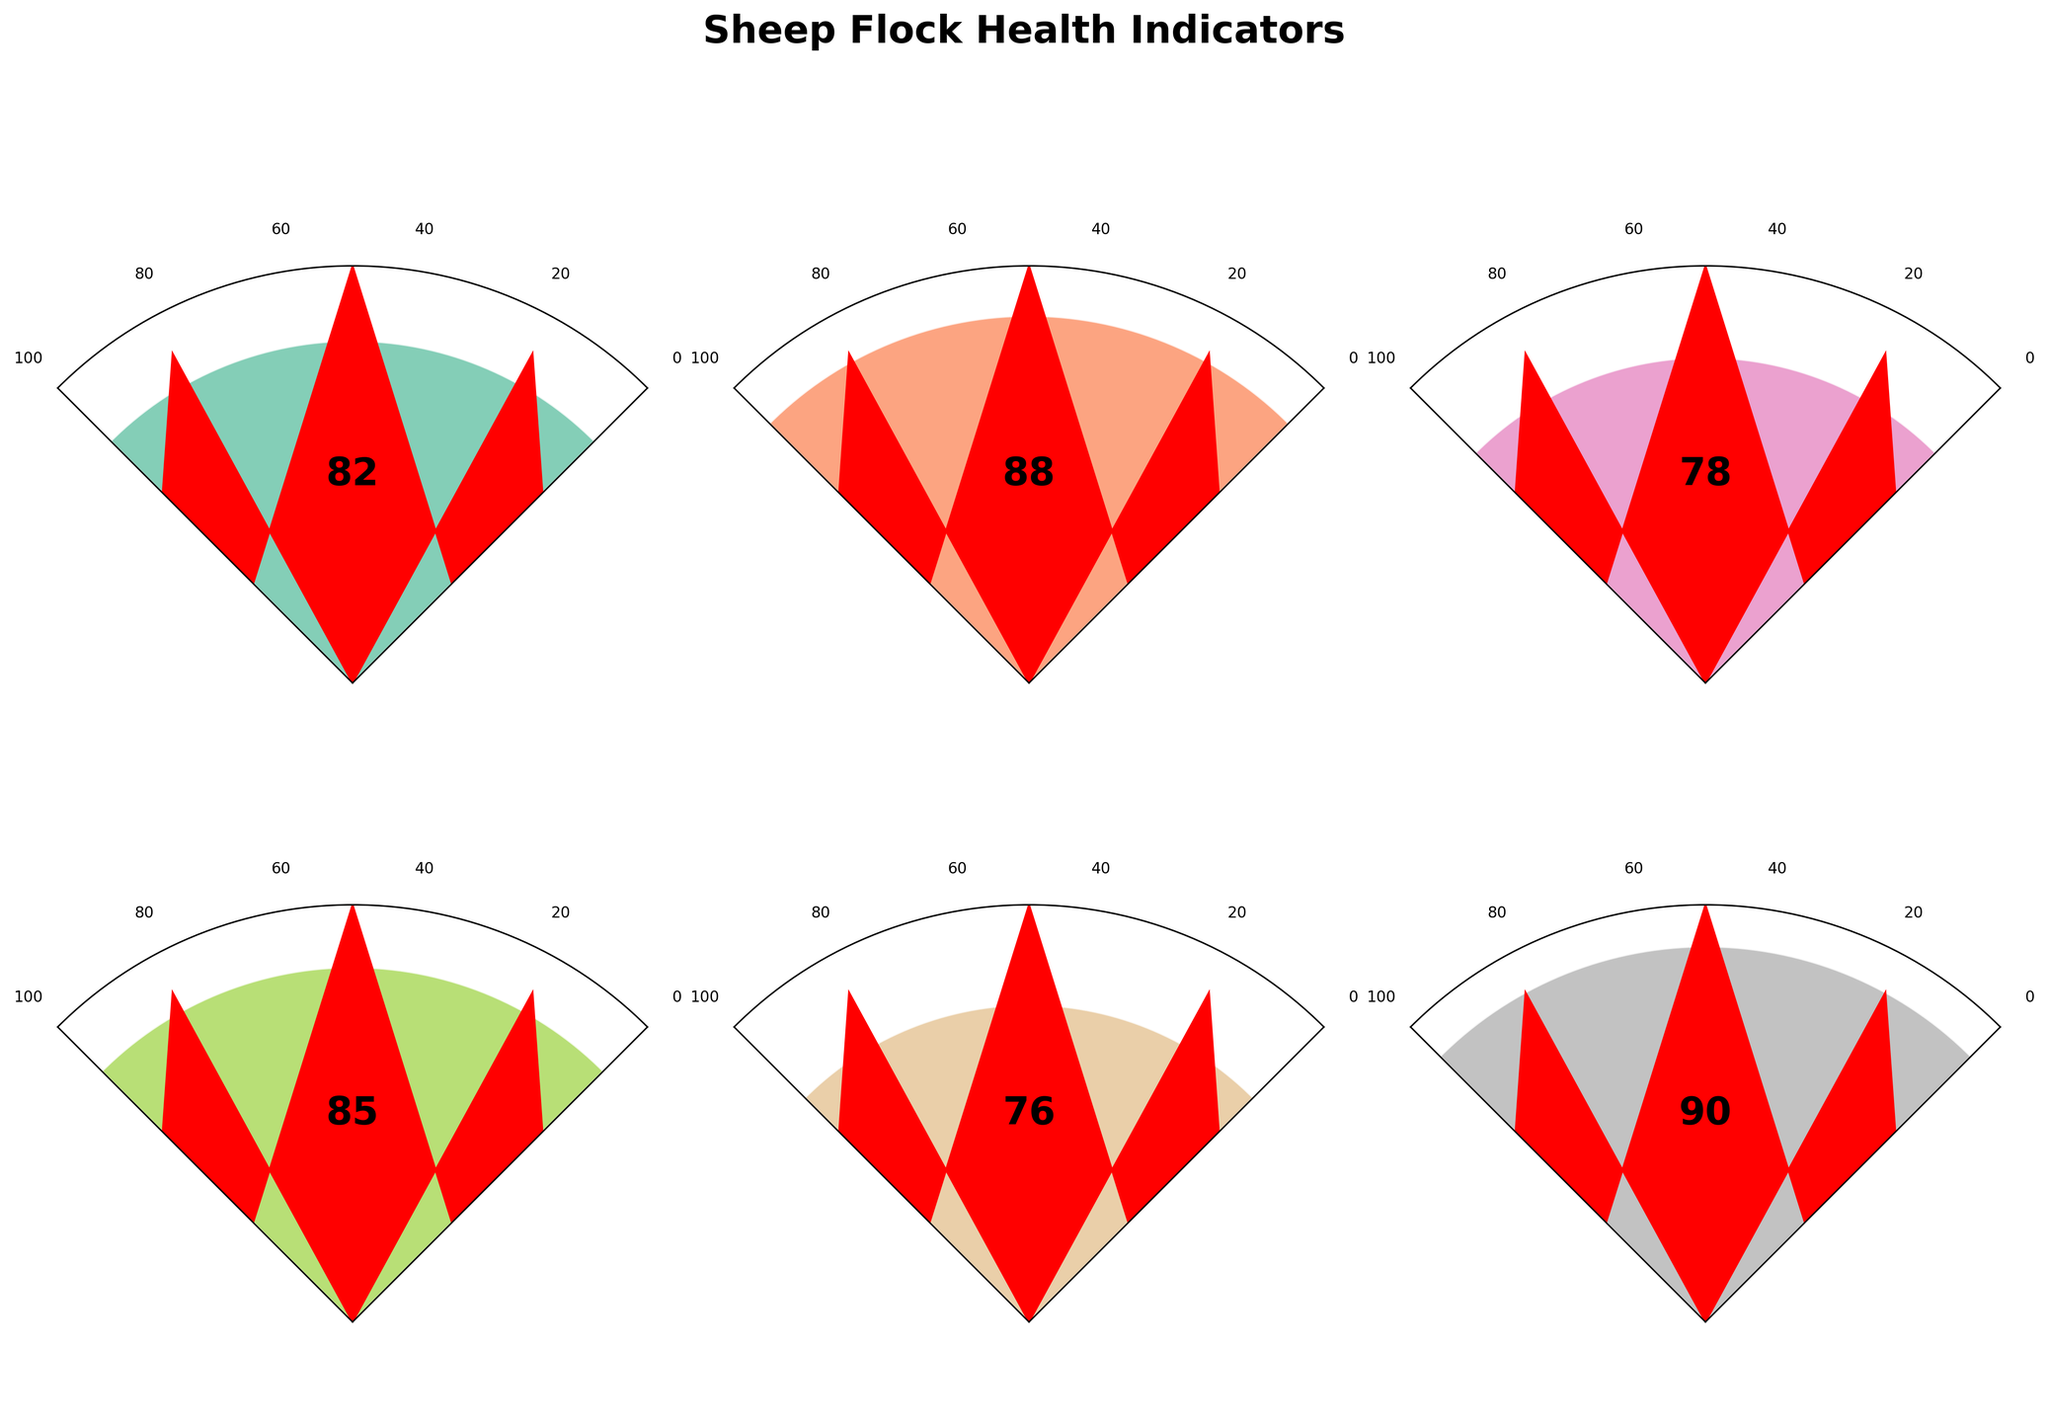What's the highest value represented across all indicators? The highest value can be identified by looking at each gauge's needle and finding the maximum. The highest needle location corresponds to the Parasite Control Efficacy indicator with a value of 90.
Answer: 90 Which indicator has the lowest value? To find the lowest value, examine the position of the needles and the numbers next to them. The lowest value is represented by the Lamb Survival Rate with a value of 76.
Answer: Lamb Survival Rate What is the total of the Nutrition Score and the Wool Quality Index? Sum the values of these two indicators: Nutrition Score (88) + Wool Quality Index (85). Therefore, 88 + 85 = 173.
Answer: 173 How does the Overall Flock Health Index compare to Disease Resistance? Compare the values directly. Overall Flock Health Index is 82 and Disease Resistance is 78. So, 82 is greater than 78.
Answer: 82 is greater What's the average value of all the indicators? To get the average, add up the values of all indicators and divide by the number of indicators: (82 + 88 + 78 + 85 + 76 + 90) / 6. The total sum is 499, and 499 / 6 ≈ 83.17.
Answer: 83.17 Which indicators have values below 80? Identify all indicators with values less than 80. These are Disease Resistance (78) and Lamb Survival Rate (76).
Answer: Disease Resistance and Lamb Survival Rate What's the difference between the highest and the lowest indicator values? Subtract the lowest value (76 for Lamb Survival Rate) from the highest value (90 for Parasite Control Efficacy): 90 - 76 = 14.
Answer: 14 Which indicators have a value higher than the average value of all indicators? First, calculate the average value (83.17). Then, check which indicators are above this value: Nutrition Score (88), Wool Quality Index (85), and Parasite Control Efficacy (90).
Answer: Nutrition Score, Wool Quality Index, Parasite Control Efficacy Which indicator is closest to the average value of all indicators? The average value is approximately 83.17. The indicators' values are: 82 (Overall Flock Health Index), 88 (Nutrition Score), 78 (Disease Resistance), 85 (Wool Quality Index), 76 (Lamb Survival Rate), and 90 (Parasite Control Efficacy). The closest value to 83.17 is 82 (Overall Flock Health Index).
Answer: Overall Flock Health Index 